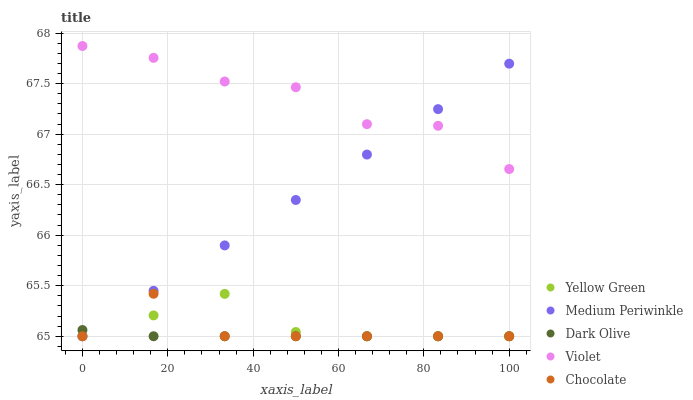Does Dark Olive have the minimum area under the curve?
Answer yes or no. Yes. Does Violet have the maximum area under the curve?
Answer yes or no. Yes. Does Medium Periwinkle have the minimum area under the curve?
Answer yes or no. No. Does Medium Periwinkle have the maximum area under the curve?
Answer yes or no. No. Is Medium Periwinkle the smoothest?
Answer yes or no. Yes. Is Violet the roughest?
Answer yes or no. Yes. Is Dark Olive the smoothest?
Answer yes or no. No. Is Dark Olive the roughest?
Answer yes or no. No. Does Chocolate have the lowest value?
Answer yes or no. Yes. Does Violet have the lowest value?
Answer yes or no. No. Does Violet have the highest value?
Answer yes or no. Yes. Does Medium Periwinkle have the highest value?
Answer yes or no. No. Is Dark Olive less than Violet?
Answer yes or no. Yes. Is Violet greater than Chocolate?
Answer yes or no. Yes. Does Medium Periwinkle intersect Violet?
Answer yes or no. Yes. Is Medium Periwinkle less than Violet?
Answer yes or no. No. Is Medium Periwinkle greater than Violet?
Answer yes or no. No. Does Dark Olive intersect Violet?
Answer yes or no. No. 